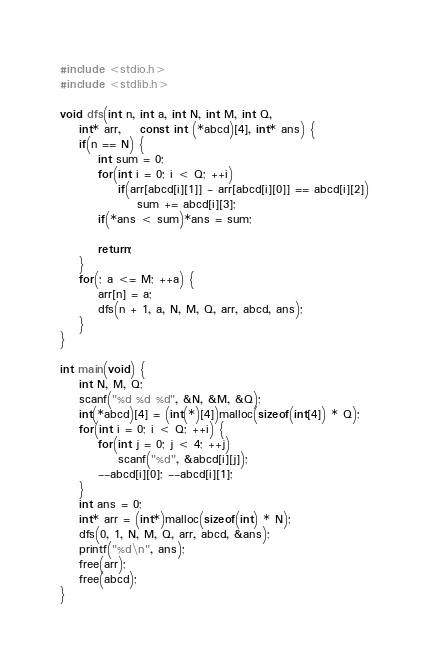<code> <loc_0><loc_0><loc_500><loc_500><_C_>#include <stdio.h>
#include <stdlib.h>

void dfs(int n, int a, int N, int M, int Q,
	int* arr,	const int (*abcd)[4], int* ans) {
	if(n == N) {
		int sum = 0;
		for(int i = 0; i < Q; ++i)
			if(arr[abcd[i][1]] - arr[abcd[i][0]] == abcd[i][2])
				sum += abcd[i][3];
		if(*ans < sum)*ans = sum;
		
		return;
	}
	for(; a <= M; ++a) {
		arr[n] = a;
		dfs(n + 1, a, N, M, Q, arr, abcd, ans);
	}
}

int main(void) {
	int N, M, Q;
	scanf("%d %d %d", &N, &M, &Q);
	int(*abcd)[4] = (int(*)[4])malloc(sizeof(int[4]) * Q);
	for(int i = 0; i < Q; ++i) {
		for(int j = 0; j < 4; ++j)
			scanf("%d", &abcd[i][j]);
		--abcd[i][0]; --abcd[i][1];
	}
	int ans = 0;
	int* arr = (int*)malloc(sizeof(int) * N);
	dfs(0, 1, N, M, Q, arr, abcd, &ans);
	printf("%d\n", ans);
	free(arr);
	free(abcd);
}
</code> 